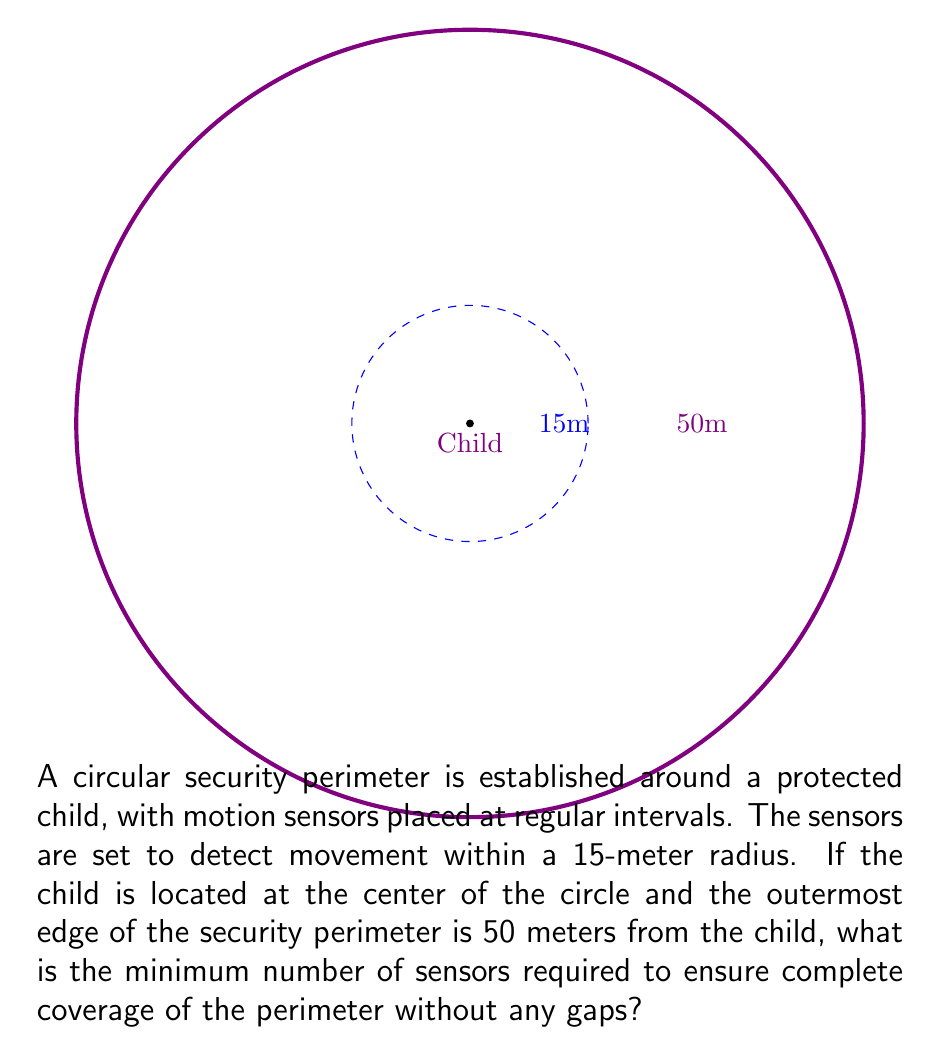Could you help me with this problem? Let's approach this step-by-step:

1) First, we need to calculate the circumference of the security perimeter:
   $$C = 2\pi r = 2\pi(50) = 100\pi \approx 314.16\text{ meters}$$

2) Each sensor covers an arc length on this circumference. To find this arc length, we need to calculate the central angle $\theta$ (in radians) that corresponds to the sensor's coverage:
   $$\sin(\frac{\theta}{2}) = \frac{15}{50}$$
   $$\frac{\theta}{2} = \arcsin(\frac{3}{10})$$
   $$\theta = 2\arcsin(\frac{3}{10}) \approx 0.6435\text{ radians}$$

3) The arc length covered by each sensor is:
   $$s = r\theta = 50(0.6435) \approx 32.175\text{ meters}$$

4) To find the number of sensors needed, we divide the total circumference by the arc length covered by each sensor:
   $$n = \frac{C}{s} = \frac{100\pi}{32.175} \approx 9.76$$

5) Since we can't have a fractional number of sensors, we need to round up to the nearest whole number to ensure complete coverage.

Therefore, the minimum number of sensors required is 10.
Answer: 10 sensors 